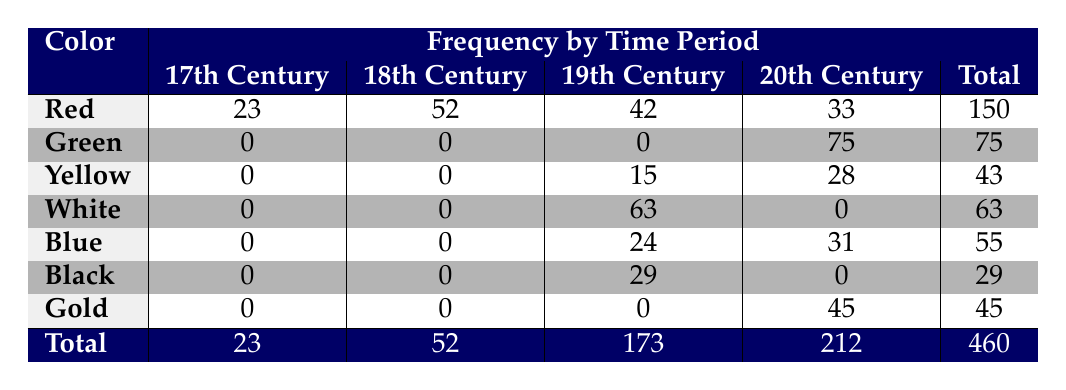What is the total frequency of the color Red in the 19th Century? The total frequency of Red in the 19th Century is the value directly listed in that row and column; it is 42.
Answer: 42 Which color has the maximum frequency in the 20th Century? By comparing the frequencies under the 20th Century column, Yellow has 28, White has 0, Blue has 31, Black has 0, Gold has 45, and Green has 75. The maximum is 75 for the color Green.
Answer: Green What is the combined frequency of colors White and Black in the 19th Century? To find the combined frequency, we take the values for White (63) and Black (29) from the 19th Century and sum them: 63 + 29 = 92.
Answer: 92 Does the color Yellow appear in the 17th Century? Looking at the 17th Century column, the value listed for Yellow is 0, indicating that Yellow does not appear in that time period.
Answer: No What is the frequency difference between the color Gold and the color Red in the 20th Century? The frequency of Gold in the 20th Century is 45, and for Red it is 33. The difference is calculated as 45 - 33 = 12.
Answer: 12 What is the total frequency of all colors across the 19th Century? To find the total frequency for the 19th Century, we add the frequencies: Red (42) + Yellow (15) + White (63) + Blue (24) + Black (29) = 173.
Answer: 173 Is the frequency of the color Blue higher than that of Red in the 20th Century? The frequency of Blue in the 20th Century is 31, while Red is 33. Since 31 is less than 33, Blue does not have a higher frequency than Red.
Answer: No How many colors have a total frequency greater than 50? From the totals, only Red (150) and Yellow (75) are greater than 50. The count is thus 2.
Answer: 2 What is the average frequency of colors in the 20th Century? First, sum the frequencies for the 20th Century: Green (75) + Yellow (28) + White (0) + Blue (31) + Black (0) + Gold (45) = 179. There are 6 colors, so the average is 179 / 6 = approximately 29.83.
Answer: 29.83 